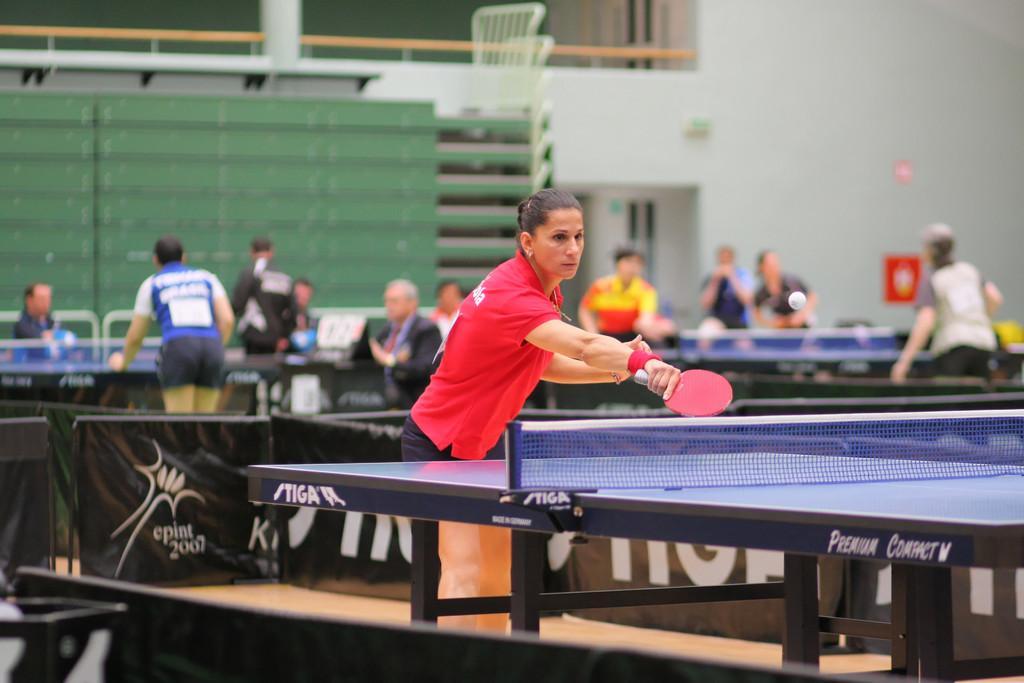Please provide a concise description of this image. This picture is clicked inside. In the foreground we can see the table of a table tennis game. On the left there is a person wearing a red color t-shirt, holding a table tennis bat and standing on the ground. In the background we can see the group of people seems to be standing on the ground and we can see the chairs and there are some people sitting on the chairs. In the background we can see the wall, doors and group of chairs placed one above the other hand there are some objects. 